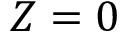Convert formula to latex. <formula><loc_0><loc_0><loc_500><loc_500>Z = 0</formula> 